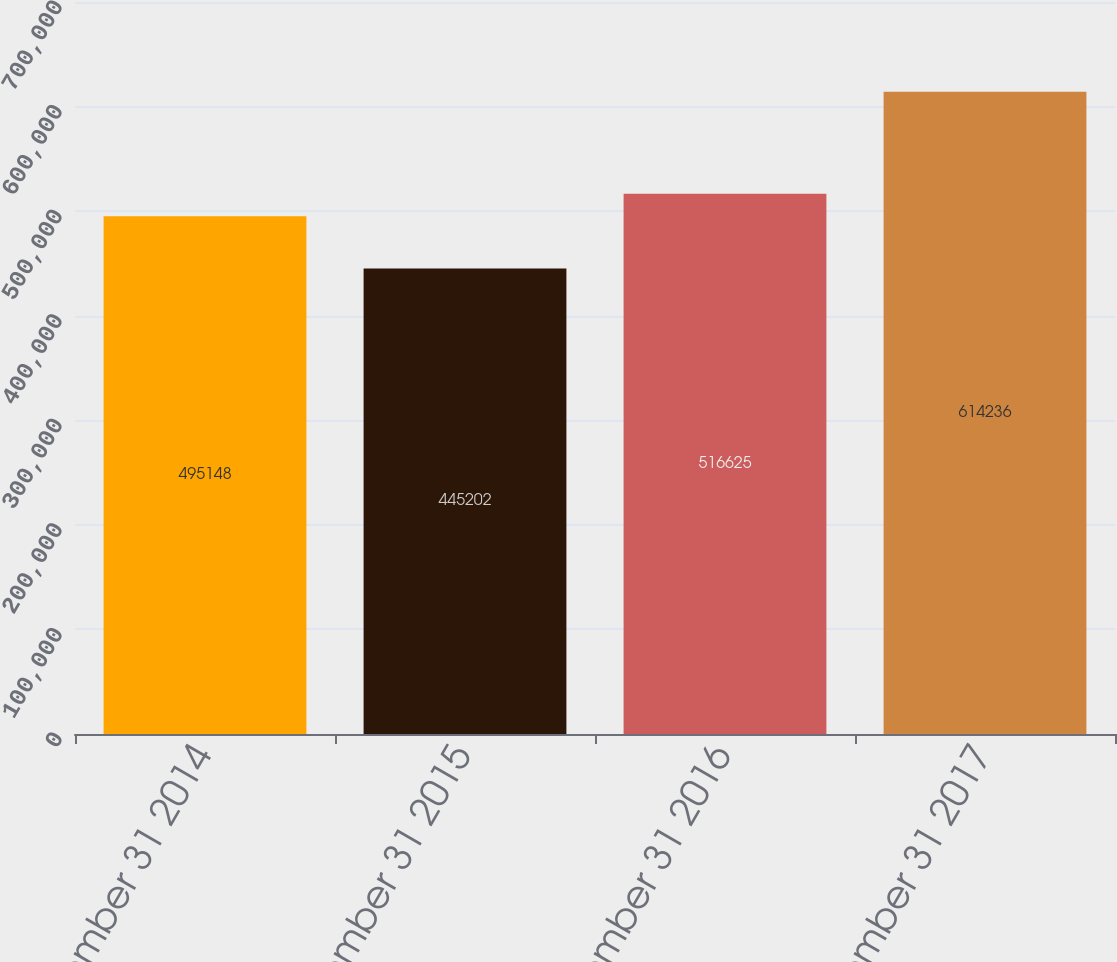Convert chart. <chart><loc_0><loc_0><loc_500><loc_500><bar_chart><fcel>December 31 2014<fcel>December 31 2015<fcel>December 31 2016<fcel>December 31 2017<nl><fcel>495148<fcel>445202<fcel>516625<fcel>614236<nl></chart> 